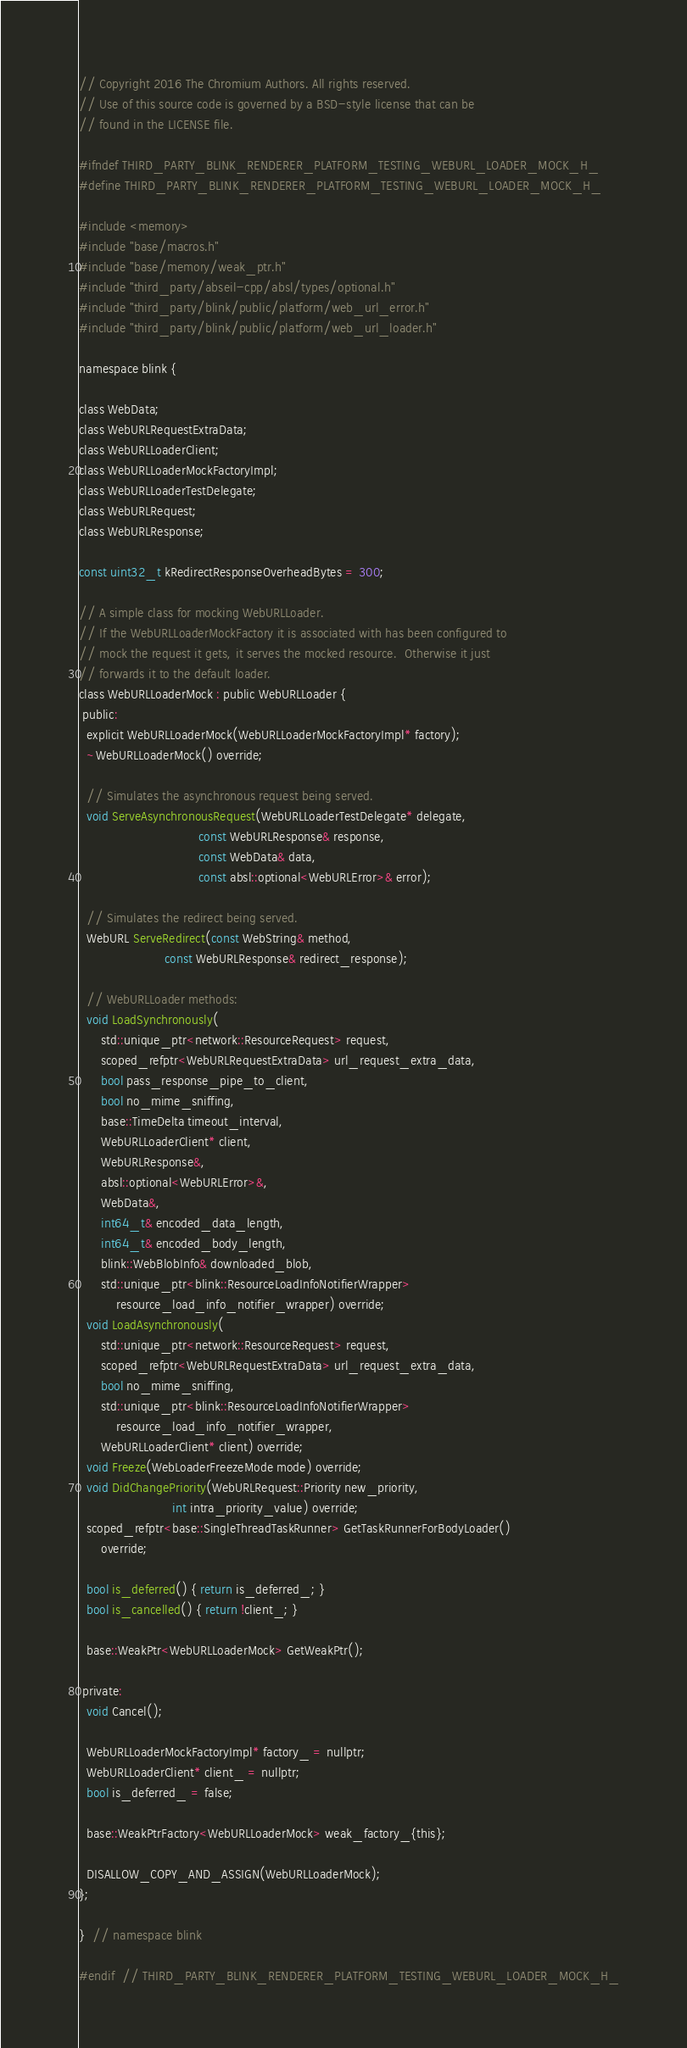<code> <loc_0><loc_0><loc_500><loc_500><_C_>// Copyright 2016 The Chromium Authors. All rights reserved.
// Use of this source code is governed by a BSD-style license that can be
// found in the LICENSE file.

#ifndef THIRD_PARTY_BLINK_RENDERER_PLATFORM_TESTING_WEBURL_LOADER_MOCK_H_
#define THIRD_PARTY_BLINK_RENDERER_PLATFORM_TESTING_WEBURL_LOADER_MOCK_H_

#include <memory>
#include "base/macros.h"
#include "base/memory/weak_ptr.h"
#include "third_party/abseil-cpp/absl/types/optional.h"
#include "third_party/blink/public/platform/web_url_error.h"
#include "third_party/blink/public/platform/web_url_loader.h"

namespace blink {

class WebData;
class WebURLRequestExtraData;
class WebURLLoaderClient;
class WebURLLoaderMockFactoryImpl;
class WebURLLoaderTestDelegate;
class WebURLRequest;
class WebURLResponse;

const uint32_t kRedirectResponseOverheadBytes = 300;

// A simple class for mocking WebURLLoader.
// If the WebURLLoaderMockFactory it is associated with has been configured to
// mock the request it gets, it serves the mocked resource.  Otherwise it just
// forwards it to the default loader.
class WebURLLoaderMock : public WebURLLoader {
 public:
  explicit WebURLLoaderMock(WebURLLoaderMockFactoryImpl* factory);
  ~WebURLLoaderMock() override;

  // Simulates the asynchronous request being served.
  void ServeAsynchronousRequest(WebURLLoaderTestDelegate* delegate,
                                const WebURLResponse& response,
                                const WebData& data,
                                const absl::optional<WebURLError>& error);

  // Simulates the redirect being served.
  WebURL ServeRedirect(const WebString& method,
                       const WebURLResponse& redirect_response);

  // WebURLLoader methods:
  void LoadSynchronously(
      std::unique_ptr<network::ResourceRequest> request,
      scoped_refptr<WebURLRequestExtraData> url_request_extra_data,
      bool pass_response_pipe_to_client,
      bool no_mime_sniffing,
      base::TimeDelta timeout_interval,
      WebURLLoaderClient* client,
      WebURLResponse&,
      absl::optional<WebURLError>&,
      WebData&,
      int64_t& encoded_data_length,
      int64_t& encoded_body_length,
      blink::WebBlobInfo& downloaded_blob,
      std::unique_ptr<blink::ResourceLoadInfoNotifierWrapper>
          resource_load_info_notifier_wrapper) override;
  void LoadAsynchronously(
      std::unique_ptr<network::ResourceRequest> request,
      scoped_refptr<WebURLRequestExtraData> url_request_extra_data,
      bool no_mime_sniffing,
      std::unique_ptr<blink::ResourceLoadInfoNotifierWrapper>
          resource_load_info_notifier_wrapper,
      WebURLLoaderClient* client) override;
  void Freeze(WebLoaderFreezeMode mode) override;
  void DidChangePriority(WebURLRequest::Priority new_priority,
                         int intra_priority_value) override;
  scoped_refptr<base::SingleThreadTaskRunner> GetTaskRunnerForBodyLoader()
      override;

  bool is_deferred() { return is_deferred_; }
  bool is_cancelled() { return !client_; }

  base::WeakPtr<WebURLLoaderMock> GetWeakPtr();

 private:
  void Cancel();

  WebURLLoaderMockFactoryImpl* factory_ = nullptr;
  WebURLLoaderClient* client_ = nullptr;
  bool is_deferred_ = false;

  base::WeakPtrFactory<WebURLLoaderMock> weak_factory_{this};

  DISALLOW_COPY_AND_ASSIGN(WebURLLoaderMock);
};

}  // namespace blink

#endif  // THIRD_PARTY_BLINK_RENDERER_PLATFORM_TESTING_WEBURL_LOADER_MOCK_H_
</code> 